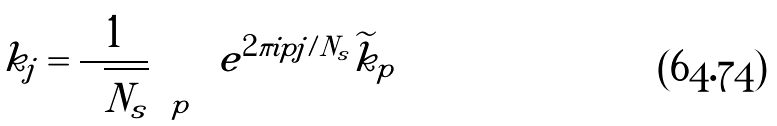Convert formula to latex. <formula><loc_0><loc_0><loc_500><loc_500>k _ { j } = \frac { 1 } { \sqrt { N _ { s } } } \sum _ { p } e ^ { 2 \pi i p j / N _ { s } } \widetilde { k } _ { p }</formula> 